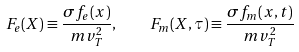<formula> <loc_0><loc_0><loc_500><loc_500>F _ { e } ( X ) \equiv \frac { \sigma f _ { e } ( x ) } { m v _ { T } ^ { 2 } } , \quad F _ { m } ( X , \tau ) \equiv \frac { \sigma f _ { m } ( x , t ) } { m v _ { T } ^ { 2 } }</formula> 